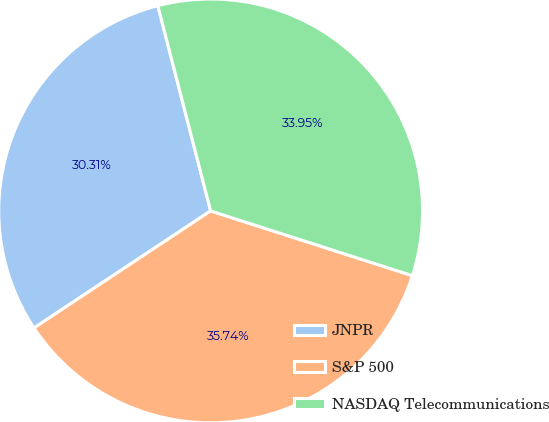Convert chart. <chart><loc_0><loc_0><loc_500><loc_500><pie_chart><fcel>JNPR<fcel>S&P 500<fcel>NASDAQ Telecommunications<nl><fcel>30.31%<fcel>35.74%<fcel>33.95%<nl></chart> 